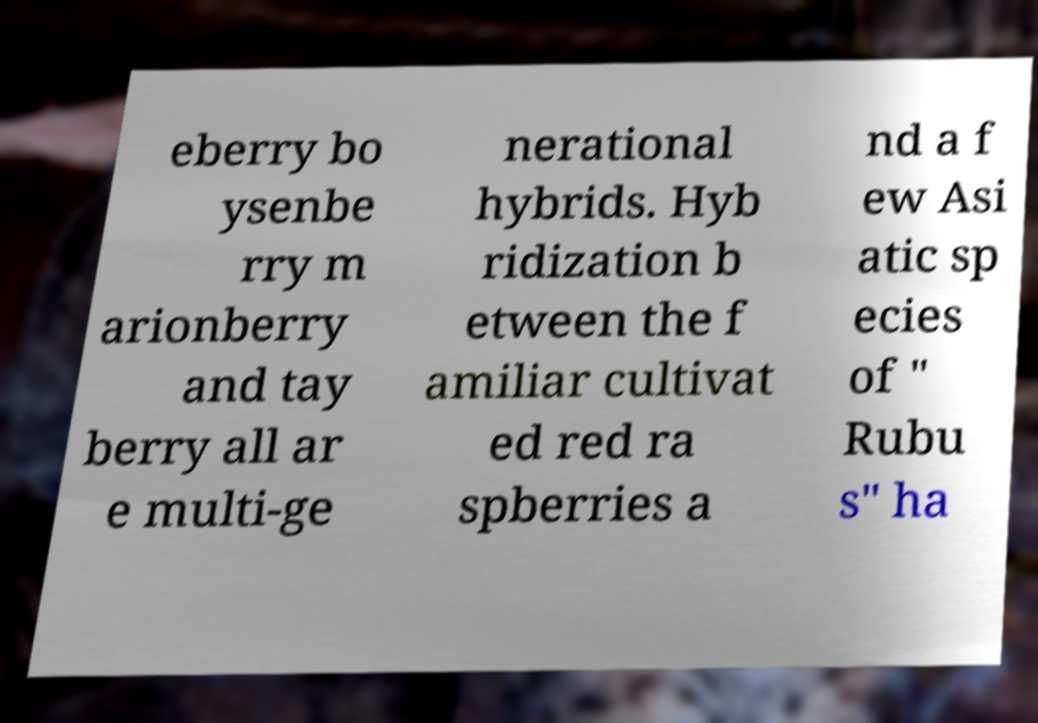Please read and relay the text visible in this image. What does it say? eberry bo ysenbe rry m arionberry and tay berry all ar e multi-ge nerational hybrids. Hyb ridization b etween the f amiliar cultivat ed red ra spberries a nd a f ew Asi atic sp ecies of " Rubu s" ha 